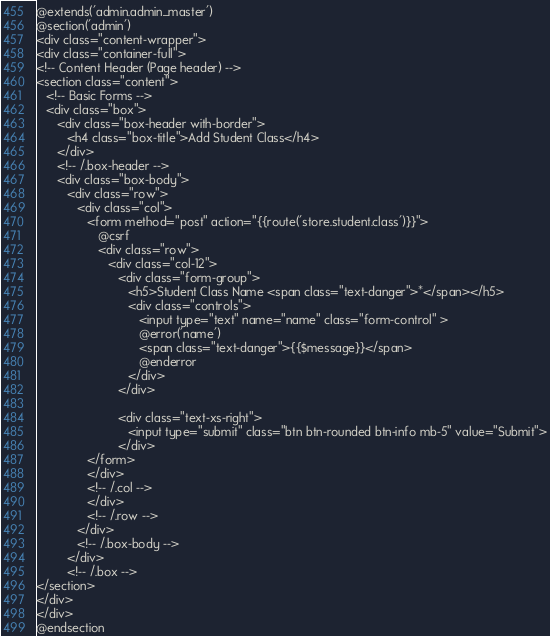Convert code to text. <code><loc_0><loc_0><loc_500><loc_500><_PHP_>@extends('admin.admin_master')
@section('admin')
<div class="content-wrapper">
<div class="container-full">
<!-- Content Header (Page header) -->
<section class="content">
   <!-- Basic Forms -->
   <div class="box">
      <div class="box-header with-border">
         <h4 class="box-title">Add Student Class</h4>
      </div>
      <!-- /.box-header -->
      <div class="box-body">
         <div class="row">
            <div class="col">
               <form method="post" action="{{route('store.student.class')}}">
                  @csrf
                  <div class="row">
                     <div class="col-12">
                        <div class="form-group">
                           <h5>Student Class Name <span class="text-danger">*</span></h5>
                           <div class="controls">
                              <input type="text" name="name" class="form-control" > 
                              @error('name')
                              <span class="text-danger">{{$message}}</span>
                              @enderror
                           </div>
                        </div>

                        <div class="text-xs-right">
                           <input type="submit" class="btn btn-rounded btn-info mb-5" value="Submit">
                        </div>
               </form>
               </div>
               <!-- /.col -->
               </div>
               <!-- /.row -->
            </div>
            <!-- /.box-body -->
         </div>
         <!-- /.box -->
</section>
</div>
</div>
@endsection</code> 